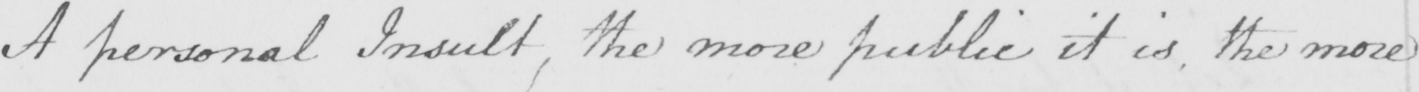What does this handwritten line say? A personal Insult , the more public it is , the more 